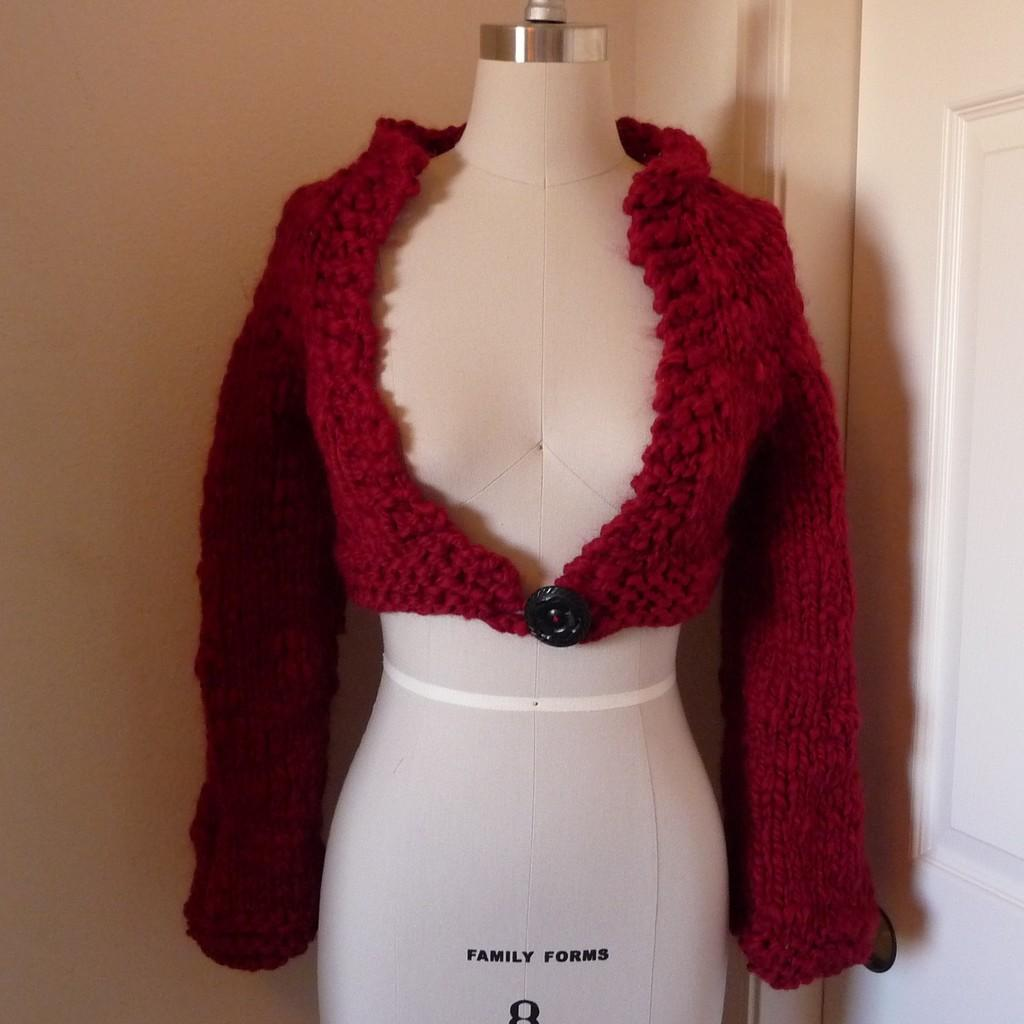What color is the jacket on the mannequin in the image? The jacket on the mannequin is red. What can be seen on the right side of the image? There is a white color door on the right side. What is visible in the background of the image? There is a wall visible in the background. What is the mannequin's opinion on the latest political debate? Mannequins do not have opinions, as they are inanimate objects. 